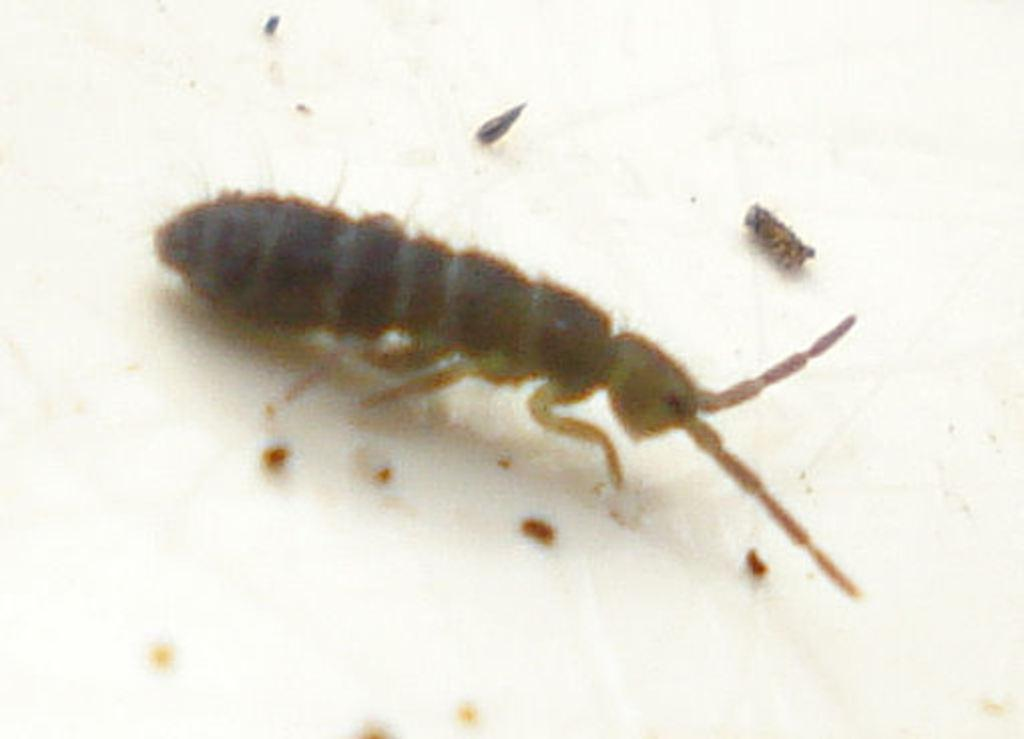What type of creature can be seen in the image? There is an insect in the image. What else is present in the image besides the insect? There are small particles in the image. What color is the surface in the image? The surface in the image is white. What type of agreement is being reached between the insect and the sink in the image? There is no sink present in the image, and therefore no agreement can be observed between the insect and a sink. 